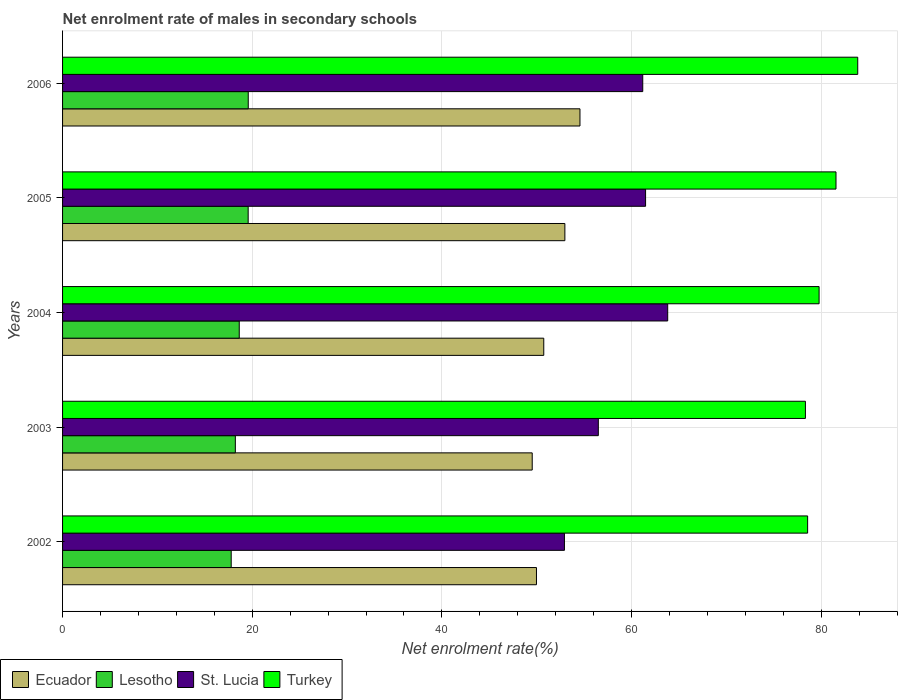How many different coloured bars are there?
Your answer should be very brief. 4. How many groups of bars are there?
Your answer should be very brief. 5. Are the number of bars per tick equal to the number of legend labels?
Ensure brevity in your answer.  Yes. Are the number of bars on each tick of the Y-axis equal?
Give a very brief answer. Yes. How many bars are there on the 5th tick from the top?
Your answer should be compact. 4. How many bars are there on the 3rd tick from the bottom?
Offer a terse response. 4. What is the label of the 3rd group of bars from the top?
Provide a short and direct response. 2004. What is the net enrolment rate of males in secondary schools in Turkey in 2003?
Your response must be concise. 78.34. Across all years, what is the maximum net enrolment rate of males in secondary schools in Turkey?
Your answer should be very brief. 83.85. Across all years, what is the minimum net enrolment rate of males in secondary schools in St. Lucia?
Make the answer very short. 52.92. In which year was the net enrolment rate of males in secondary schools in Ecuador maximum?
Ensure brevity in your answer.  2006. In which year was the net enrolment rate of males in secondary schools in Turkey minimum?
Provide a short and direct response. 2003. What is the total net enrolment rate of males in secondary schools in Turkey in the graph?
Offer a terse response. 402.09. What is the difference between the net enrolment rate of males in secondary schools in St. Lucia in 2003 and that in 2005?
Keep it short and to the point. -4.98. What is the difference between the net enrolment rate of males in secondary schools in St. Lucia in 2004 and the net enrolment rate of males in secondary schools in Lesotho in 2003?
Offer a very short reply. 45.59. What is the average net enrolment rate of males in secondary schools in Ecuador per year?
Offer a very short reply. 51.55. In the year 2005, what is the difference between the net enrolment rate of males in secondary schools in Ecuador and net enrolment rate of males in secondary schools in Turkey?
Your answer should be compact. -28.59. What is the ratio of the net enrolment rate of males in secondary schools in Ecuador in 2004 to that in 2006?
Make the answer very short. 0.93. Is the net enrolment rate of males in secondary schools in Turkey in 2002 less than that in 2006?
Keep it short and to the point. Yes. Is the difference between the net enrolment rate of males in secondary schools in Ecuador in 2002 and 2004 greater than the difference between the net enrolment rate of males in secondary schools in Turkey in 2002 and 2004?
Provide a succinct answer. Yes. What is the difference between the highest and the second highest net enrolment rate of males in secondary schools in Turkey?
Your answer should be very brief. 2.29. What is the difference between the highest and the lowest net enrolment rate of males in secondary schools in Turkey?
Keep it short and to the point. 5.52. Is the sum of the net enrolment rate of males in secondary schools in St. Lucia in 2002 and 2005 greater than the maximum net enrolment rate of males in secondary schools in Lesotho across all years?
Provide a succinct answer. Yes. Is it the case that in every year, the sum of the net enrolment rate of males in secondary schools in St. Lucia and net enrolment rate of males in secondary schools in Ecuador is greater than the sum of net enrolment rate of males in secondary schools in Lesotho and net enrolment rate of males in secondary schools in Turkey?
Offer a terse response. No. What does the 4th bar from the top in 2004 represents?
Offer a very short reply. Ecuador. What does the 2nd bar from the bottom in 2005 represents?
Keep it short and to the point. Lesotho. Are all the bars in the graph horizontal?
Offer a terse response. Yes. How many years are there in the graph?
Keep it short and to the point. 5. Does the graph contain grids?
Ensure brevity in your answer.  Yes. Where does the legend appear in the graph?
Offer a terse response. Bottom left. What is the title of the graph?
Your answer should be very brief. Net enrolment rate of males in secondary schools. Does "Azerbaijan" appear as one of the legend labels in the graph?
Ensure brevity in your answer.  No. What is the label or title of the X-axis?
Make the answer very short. Net enrolment rate(%). What is the label or title of the Y-axis?
Offer a terse response. Years. What is the Net enrolment rate(%) of Ecuador in 2002?
Offer a terse response. 49.97. What is the Net enrolment rate(%) in Lesotho in 2002?
Provide a succinct answer. 17.78. What is the Net enrolment rate(%) of St. Lucia in 2002?
Keep it short and to the point. 52.92. What is the Net enrolment rate(%) in Turkey in 2002?
Your response must be concise. 78.57. What is the Net enrolment rate(%) of Ecuador in 2003?
Your response must be concise. 49.53. What is the Net enrolment rate(%) of Lesotho in 2003?
Offer a terse response. 18.22. What is the Net enrolment rate(%) of St. Lucia in 2003?
Provide a succinct answer. 56.5. What is the Net enrolment rate(%) in Turkey in 2003?
Provide a succinct answer. 78.34. What is the Net enrolment rate(%) in Ecuador in 2004?
Keep it short and to the point. 50.74. What is the Net enrolment rate(%) in Lesotho in 2004?
Your response must be concise. 18.63. What is the Net enrolment rate(%) of St. Lucia in 2004?
Keep it short and to the point. 63.81. What is the Net enrolment rate(%) in Turkey in 2004?
Your answer should be compact. 79.78. What is the Net enrolment rate(%) of Ecuador in 2005?
Offer a terse response. 52.97. What is the Net enrolment rate(%) in Lesotho in 2005?
Provide a succinct answer. 19.57. What is the Net enrolment rate(%) in St. Lucia in 2005?
Your answer should be compact. 61.48. What is the Net enrolment rate(%) of Turkey in 2005?
Give a very brief answer. 81.56. What is the Net enrolment rate(%) in Ecuador in 2006?
Give a very brief answer. 54.56. What is the Net enrolment rate(%) in Lesotho in 2006?
Give a very brief answer. 19.58. What is the Net enrolment rate(%) in St. Lucia in 2006?
Provide a succinct answer. 61.18. What is the Net enrolment rate(%) in Turkey in 2006?
Offer a terse response. 83.85. Across all years, what is the maximum Net enrolment rate(%) of Ecuador?
Your answer should be compact. 54.56. Across all years, what is the maximum Net enrolment rate(%) of Lesotho?
Your response must be concise. 19.58. Across all years, what is the maximum Net enrolment rate(%) in St. Lucia?
Your answer should be compact. 63.81. Across all years, what is the maximum Net enrolment rate(%) in Turkey?
Your response must be concise. 83.85. Across all years, what is the minimum Net enrolment rate(%) of Ecuador?
Offer a very short reply. 49.53. Across all years, what is the minimum Net enrolment rate(%) of Lesotho?
Keep it short and to the point. 17.78. Across all years, what is the minimum Net enrolment rate(%) of St. Lucia?
Offer a terse response. 52.92. Across all years, what is the minimum Net enrolment rate(%) in Turkey?
Provide a succinct answer. 78.34. What is the total Net enrolment rate(%) in Ecuador in the graph?
Your answer should be very brief. 257.77. What is the total Net enrolment rate(%) of Lesotho in the graph?
Offer a very short reply. 93.79. What is the total Net enrolment rate(%) in St. Lucia in the graph?
Ensure brevity in your answer.  295.89. What is the total Net enrolment rate(%) of Turkey in the graph?
Give a very brief answer. 402.09. What is the difference between the Net enrolment rate(%) in Ecuador in 2002 and that in 2003?
Your answer should be very brief. 0.45. What is the difference between the Net enrolment rate(%) of Lesotho in 2002 and that in 2003?
Keep it short and to the point. -0.44. What is the difference between the Net enrolment rate(%) of St. Lucia in 2002 and that in 2003?
Provide a succinct answer. -3.57. What is the difference between the Net enrolment rate(%) in Turkey in 2002 and that in 2003?
Make the answer very short. 0.23. What is the difference between the Net enrolment rate(%) in Ecuador in 2002 and that in 2004?
Your answer should be compact. -0.77. What is the difference between the Net enrolment rate(%) of Lesotho in 2002 and that in 2004?
Your response must be concise. -0.85. What is the difference between the Net enrolment rate(%) of St. Lucia in 2002 and that in 2004?
Give a very brief answer. -10.89. What is the difference between the Net enrolment rate(%) in Turkey in 2002 and that in 2004?
Keep it short and to the point. -1.21. What is the difference between the Net enrolment rate(%) of Ecuador in 2002 and that in 2005?
Provide a succinct answer. -3. What is the difference between the Net enrolment rate(%) of Lesotho in 2002 and that in 2005?
Make the answer very short. -1.79. What is the difference between the Net enrolment rate(%) of St. Lucia in 2002 and that in 2005?
Offer a terse response. -8.56. What is the difference between the Net enrolment rate(%) in Turkey in 2002 and that in 2005?
Ensure brevity in your answer.  -2.99. What is the difference between the Net enrolment rate(%) in Ecuador in 2002 and that in 2006?
Make the answer very short. -4.59. What is the difference between the Net enrolment rate(%) of Lesotho in 2002 and that in 2006?
Provide a succinct answer. -1.8. What is the difference between the Net enrolment rate(%) of St. Lucia in 2002 and that in 2006?
Ensure brevity in your answer.  -8.26. What is the difference between the Net enrolment rate(%) of Turkey in 2002 and that in 2006?
Offer a terse response. -5.28. What is the difference between the Net enrolment rate(%) in Ecuador in 2003 and that in 2004?
Offer a terse response. -1.22. What is the difference between the Net enrolment rate(%) of Lesotho in 2003 and that in 2004?
Offer a very short reply. -0.41. What is the difference between the Net enrolment rate(%) in St. Lucia in 2003 and that in 2004?
Keep it short and to the point. -7.32. What is the difference between the Net enrolment rate(%) of Turkey in 2003 and that in 2004?
Offer a terse response. -1.44. What is the difference between the Net enrolment rate(%) in Ecuador in 2003 and that in 2005?
Offer a terse response. -3.44. What is the difference between the Net enrolment rate(%) of Lesotho in 2003 and that in 2005?
Your answer should be compact. -1.35. What is the difference between the Net enrolment rate(%) in St. Lucia in 2003 and that in 2005?
Keep it short and to the point. -4.98. What is the difference between the Net enrolment rate(%) in Turkey in 2003 and that in 2005?
Keep it short and to the point. -3.22. What is the difference between the Net enrolment rate(%) of Ecuador in 2003 and that in 2006?
Offer a very short reply. -5.04. What is the difference between the Net enrolment rate(%) in Lesotho in 2003 and that in 2006?
Ensure brevity in your answer.  -1.36. What is the difference between the Net enrolment rate(%) of St. Lucia in 2003 and that in 2006?
Your answer should be very brief. -4.68. What is the difference between the Net enrolment rate(%) in Turkey in 2003 and that in 2006?
Offer a terse response. -5.52. What is the difference between the Net enrolment rate(%) in Ecuador in 2004 and that in 2005?
Offer a very short reply. -2.23. What is the difference between the Net enrolment rate(%) in Lesotho in 2004 and that in 2005?
Ensure brevity in your answer.  -0.94. What is the difference between the Net enrolment rate(%) of St. Lucia in 2004 and that in 2005?
Offer a very short reply. 2.33. What is the difference between the Net enrolment rate(%) of Turkey in 2004 and that in 2005?
Keep it short and to the point. -1.78. What is the difference between the Net enrolment rate(%) of Ecuador in 2004 and that in 2006?
Provide a short and direct response. -3.82. What is the difference between the Net enrolment rate(%) in Lesotho in 2004 and that in 2006?
Offer a very short reply. -0.95. What is the difference between the Net enrolment rate(%) in St. Lucia in 2004 and that in 2006?
Offer a very short reply. 2.63. What is the difference between the Net enrolment rate(%) of Turkey in 2004 and that in 2006?
Provide a succinct answer. -4.07. What is the difference between the Net enrolment rate(%) in Ecuador in 2005 and that in 2006?
Provide a short and direct response. -1.59. What is the difference between the Net enrolment rate(%) in Lesotho in 2005 and that in 2006?
Ensure brevity in your answer.  -0.01. What is the difference between the Net enrolment rate(%) of St. Lucia in 2005 and that in 2006?
Keep it short and to the point. 0.3. What is the difference between the Net enrolment rate(%) of Turkey in 2005 and that in 2006?
Your response must be concise. -2.29. What is the difference between the Net enrolment rate(%) in Ecuador in 2002 and the Net enrolment rate(%) in Lesotho in 2003?
Ensure brevity in your answer.  31.75. What is the difference between the Net enrolment rate(%) of Ecuador in 2002 and the Net enrolment rate(%) of St. Lucia in 2003?
Provide a succinct answer. -6.52. What is the difference between the Net enrolment rate(%) of Ecuador in 2002 and the Net enrolment rate(%) of Turkey in 2003?
Provide a succinct answer. -28.36. What is the difference between the Net enrolment rate(%) in Lesotho in 2002 and the Net enrolment rate(%) in St. Lucia in 2003?
Keep it short and to the point. -38.72. What is the difference between the Net enrolment rate(%) of Lesotho in 2002 and the Net enrolment rate(%) of Turkey in 2003?
Provide a short and direct response. -60.55. What is the difference between the Net enrolment rate(%) in St. Lucia in 2002 and the Net enrolment rate(%) in Turkey in 2003?
Your answer should be very brief. -25.41. What is the difference between the Net enrolment rate(%) of Ecuador in 2002 and the Net enrolment rate(%) of Lesotho in 2004?
Provide a short and direct response. 31.34. What is the difference between the Net enrolment rate(%) in Ecuador in 2002 and the Net enrolment rate(%) in St. Lucia in 2004?
Your response must be concise. -13.84. What is the difference between the Net enrolment rate(%) in Ecuador in 2002 and the Net enrolment rate(%) in Turkey in 2004?
Keep it short and to the point. -29.8. What is the difference between the Net enrolment rate(%) of Lesotho in 2002 and the Net enrolment rate(%) of St. Lucia in 2004?
Make the answer very short. -46.03. What is the difference between the Net enrolment rate(%) in Lesotho in 2002 and the Net enrolment rate(%) in Turkey in 2004?
Provide a short and direct response. -61.99. What is the difference between the Net enrolment rate(%) of St. Lucia in 2002 and the Net enrolment rate(%) of Turkey in 2004?
Your answer should be very brief. -26.85. What is the difference between the Net enrolment rate(%) in Ecuador in 2002 and the Net enrolment rate(%) in Lesotho in 2005?
Your response must be concise. 30.4. What is the difference between the Net enrolment rate(%) in Ecuador in 2002 and the Net enrolment rate(%) in St. Lucia in 2005?
Offer a very short reply. -11.51. What is the difference between the Net enrolment rate(%) in Ecuador in 2002 and the Net enrolment rate(%) in Turkey in 2005?
Your response must be concise. -31.59. What is the difference between the Net enrolment rate(%) in Lesotho in 2002 and the Net enrolment rate(%) in St. Lucia in 2005?
Make the answer very short. -43.7. What is the difference between the Net enrolment rate(%) in Lesotho in 2002 and the Net enrolment rate(%) in Turkey in 2005?
Make the answer very short. -63.78. What is the difference between the Net enrolment rate(%) in St. Lucia in 2002 and the Net enrolment rate(%) in Turkey in 2005?
Ensure brevity in your answer.  -28.64. What is the difference between the Net enrolment rate(%) in Ecuador in 2002 and the Net enrolment rate(%) in Lesotho in 2006?
Provide a short and direct response. 30.39. What is the difference between the Net enrolment rate(%) of Ecuador in 2002 and the Net enrolment rate(%) of St. Lucia in 2006?
Keep it short and to the point. -11.21. What is the difference between the Net enrolment rate(%) in Ecuador in 2002 and the Net enrolment rate(%) in Turkey in 2006?
Provide a short and direct response. -33.88. What is the difference between the Net enrolment rate(%) in Lesotho in 2002 and the Net enrolment rate(%) in St. Lucia in 2006?
Offer a terse response. -43.4. What is the difference between the Net enrolment rate(%) in Lesotho in 2002 and the Net enrolment rate(%) in Turkey in 2006?
Keep it short and to the point. -66.07. What is the difference between the Net enrolment rate(%) of St. Lucia in 2002 and the Net enrolment rate(%) of Turkey in 2006?
Ensure brevity in your answer.  -30.93. What is the difference between the Net enrolment rate(%) in Ecuador in 2003 and the Net enrolment rate(%) in Lesotho in 2004?
Provide a short and direct response. 30.89. What is the difference between the Net enrolment rate(%) of Ecuador in 2003 and the Net enrolment rate(%) of St. Lucia in 2004?
Offer a very short reply. -14.29. What is the difference between the Net enrolment rate(%) in Ecuador in 2003 and the Net enrolment rate(%) in Turkey in 2004?
Provide a short and direct response. -30.25. What is the difference between the Net enrolment rate(%) of Lesotho in 2003 and the Net enrolment rate(%) of St. Lucia in 2004?
Keep it short and to the point. -45.59. What is the difference between the Net enrolment rate(%) in Lesotho in 2003 and the Net enrolment rate(%) in Turkey in 2004?
Offer a very short reply. -61.56. What is the difference between the Net enrolment rate(%) of St. Lucia in 2003 and the Net enrolment rate(%) of Turkey in 2004?
Offer a terse response. -23.28. What is the difference between the Net enrolment rate(%) of Ecuador in 2003 and the Net enrolment rate(%) of Lesotho in 2005?
Provide a succinct answer. 29.95. What is the difference between the Net enrolment rate(%) of Ecuador in 2003 and the Net enrolment rate(%) of St. Lucia in 2005?
Provide a short and direct response. -11.95. What is the difference between the Net enrolment rate(%) of Ecuador in 2003 and the Net enrolment rate(%) of Turkey in 2005?
Provide a short and direct response. -32.03. What is the difference between the Net enrolment rate(%) of Lesotho in 2003 and the Net enrolment rate(%) of St. Lucia in 2005?
Ensure brevity in your answer.  -43.26. What is the difference between the Net enrolment rate(%) in Lesotho in 2003 and the Net enrolment rate(%) in Turkey in 2005?
Ensure brevity in your answer.  -63.34. What is the difference between the Net enrolment rate(%) of St. Lucia in 2003 and the Net enrolment rate(%) of Turkey in 2005?
Ensure brevity in your answer.  -25.06. What is the difference between the Net enrolment rate(%) of Ecuador in 2003 and the Net enrolment rate(%) of Lesotho in 2006?
Your answer should be compact. 29.95. What is the difference between the Net enrolment rate(%) of Ecuador in 2003 and the Net enrolment rate(%) of St. Lucia in 2006?
Offer a terse response. -11.66. What is the difference between the Net enrolment rate(%) of Ecuador in 2003 and the Net enrolment rate(%) of Turkey in 2006?
Offer a very short reply. -34.33. What is the difference between the Net enrolment rate(%) in Lesotho in 2003 and the Net enrolment rate(%) in St. Lucia in 2006?
Provide a succinct answer. -42.96. What is the difference between the Net enrolment rate(%) in Lesotho in 2003 and the Net enrolment rate(%) in Turkey in 2006?
Offer a terse response. -65.63. What is the difference between the Net enrolment rate(%) of St. Lucia in 2003 and the Net enrolment rate(%) of Turkey in 2006?
Offer a very short reply. -27.35. What is the difference between the Net enrolment rate(%) in Ecuador in 2004 and the Net enrolment rate(%) in Lesotho in 2005?
Keep it short and to the point. 31.17. What is the difference between the Net enrolment rate(%) in Ecuador in 2004 and the Net enrolment rate(%) in St. Lucia in 2005?
Make the answer very short. -10.74. What is the difference between the Net enrolment rate(%) in Ecuador in 2004 and the Net enrolment rate(%) in Turkey in 2005?
Provide a succinct answer. -30.82. What is the difference between the Net enrolment rate(%) of Lesotho in 2004 and the Net enrolment rate(%) of St. Lucia in 2005?
Provide a succinct answer. -42.85. What is the difference between the Net enrolment rate(%) in Lesotho in 2004 and the Net enrolment rate(%) in Turkey in 2005?
Offer a terse response. -62.93. What is the difference between the Net enrolment rate(%) in St. Lucia in 2004 and the Net enrolment rate(%) in Turkey in 2005?
Offer a very short reply. -17.75. What is the difference between the Net enrolment rate(%) in Ecuador in 2004 and the Net enrolment rate(%) in Lesotho in 2006?
Provide a short and direct response. 31.16. What is the difference between the Net enrolment rate(%) in Ecuador in 2004 and the Net enrolment rate(%) in St. Lucia in 2006?
Your answer should be compact. -10.44. What is the difference between the Net enrolment rate(%) in Ecuador in 2004 and the Net enrolment rate(%) in Turkey in 2006?
Your response must be concise. -33.11. What is the difference between the Net enrolment rate(%) in Lesotho in 2004 and the Net enrolment rate(%) in St. Lucia in 2006?
Offer a terse response. -42.55. What is the difference between the Net enrolment rate(%) of Lesotho in 2004 and the Net enrolment rate(%) of Turkey in 2006?
Provide a short and direct response. -65.22. What is the difference between the Net enrolment rate(%) of St. Lucia in 2004 and the Net enrolment rate(%) of Turkey in 2006?
Your answer should be very brief. -20.04. What is the difference between the Net enrolment rate(%) of Ecuador in 2005 and the Net enrolment rate(%) of Lesotho in 2006?
Keep it short and to the point. 33.39. What is the difference between the Net enrolment rate(%) of Ecuador in 2005 and the Net enrolment rate(%) of St. Lucia in 2006?
Ensure brevity in your answer.  -8.21. What is the difference between the Net enrolment rate(%) of Ecuador in 2005 and the Net enrolment rate(%) of Turkey in 2006?
Offer a terse response. -30.88. What is the difference between the Net enrolment rate(%) in Lesotho in 2005 and the Net enrolment rate(%) in St. Lucia in 2006?
Provide a short and direct response. -41.61. What is the difference between the Net enrolment rate(%) in Lesotho in 2005 and the Net enrolment rate(%) in Turkey in 2006?
Offer a terse response. -64.28. What is the difference between the Net enrolment rate(%) of St. Lucia in 2005 and the Net enrolment rate(%) of Turkey in 2006?
Your answer should be very brief. -22.37. What is the average Net enrolment rate(%) in Ecuador per year?
Keep it short and to the point. 51.55. What is the average Net enrolment rate(%) in Lesotho per year?
Your response must be concise. 18.76. What is the average Net enrolment rate(%) in St. Lucia per year?
Keep it short and to the point. 59.18. What is the average Net enrolment rate(%) of Turkey per year?
Give a very brief answer. 80.42. In the year 2002, what is the difference between the Net enrolment rate(%) of Ecuador and Net enrolment rate(%) of Lesotho?
Offer a very short reply. 32.19. In the year 2002, what is the difference between the Net enrolment rate(%) in Ecuador and Net enrolment rate(%) in St. Lucia?
Ensure brevity in your answer.  -2.95. In the year 2002, what is the difference between the Net enrolment rate(%) in Ecuador and Net enrolment rate(%) in Turkey?
Offer a very short reply. -28.59. In the year 2002, what is the difference between the Net enrolment rate(%) in Lesotho and Net enrolment rate(%) in St. Lucia?
Keep it short and to the point. -35.14. In the year 2002, what is the difference between the Net enrolment rate(%) of Lesotho and Net enrolment rate(%) of Turkey?
Provide a short and direct response. -60.78. In the year 2002, what is the difference between the Net enrolment rate(%) in St. Lucia and Net enrolment rate(%) in Turkey?
Your answer should be very brief. -25.64. In the year 2003, what is the difference between the Net enrolment rate(%) in Ecuador and Net enrolment rate(%) in Lesotho?
Ensure brevity in your answer.  31.31. In the year 2003, what is the difference between the Net enrolment rate(%) in Ecuador and Net enrolment rate(%) in St. Lucia?
Your response must be concise. -6.97. In the year 2003, what is the difference between the Net enrolment rate(%) in Ecuador and Net enrolment rate(%) in Turkey?
Keep it short and to the point. -28.81. In the year 2003, what is the difference between the Net enrolment rate(%) in Lesotho and Net enrolment rate(%) in St. Lucia?
Provide a short and direct response. -38.28. In the year 2003, what is the difference between the Net enrolment rate(%) of Lesotho and Net enrolment rate(%) of Turkey?
Give a very brief answer. -60.12. In the year 2003, what is the difference between the Net enrolment rate(%) of St. Lucia and Net enrolment rate(%) of Turkey?
Offer a terse response. -21.84. In the year 2004, what is the difference between the Net enrolment rate(%) in Ecuador and Net enrolment rate(%) in Lesotho?
Ensure brevity in your answer.  32.11. In the year 2004, what is the difference between the Net enrolment rate(%) of Ecuador and Net enrolment rate(%) of St. Lucia?
Your answer should be compact. -13.07. In the year 2004, what is the difference between the Net enrolment rate(%) in Ecuador and Net enrolment rate(%) in Turkey?
Your answer should be compact. -29.03. In the year 2004, what is the difference between the Net enrolment rate(%) of Lesotho and Net enrolment rate(%) of St. Lucia?
Ensure brevity in your answer.  -45.18. In the year 2004, what is the difference between the Net enrolment rate(%) of Lesotho and Net enrolment rate(%) of Turkey?
Keep it short and to the point. -61.15. In the year 2004, what is the difference between the Net enrolment rate(%) in St. Lucia and Net enrolment rate(%) in Turkey?
Provide a succinct answer. -15.96. In the year 2005, what is the difference between the Net enrolment rate(%) of Ecuador and Net enrolment rate(%) of Lesotho?
Make the answer very short. 33.4. In the year 2005, what is the difference between the Net enrolment rate(%) of Ecuador and Net enrolment rate(%) of St. Lucia?
Give a very brief answer. -8.51. In the year 2005, what is the difference between the Net enrolment rate(%) of Ecuador and Net enrolment rate(%) of Turkey?
Give a very brief answer. -28.59. In the year 2005, what is the difference between the Net enrolment rate(%) of Lesotho and Net enrolment rate(%) of St. Lucia?
Give a very brief answer. -41.91. In the year 2005, what is the difference between the Net enrolment rate(%) in Lesotho and Net enrolment rate(%) in Turkey?
Your response must be concise. -61.99. In the year 2005, what is the difference between the Net enrolment rate(%) in St. Lucia and Net enrolment rate(%) in Turkey?
Give a very brief answer. -20.08. In the year 2006, what is the difference between the Net enrolment rate(%) of Ecuador and Net enrolment rate(%) of Lesotho?
Offer a terse response. 34.98. In the year 2006, what is the difference between the Net enrolment rate(%) of Ecuador and Net enrolment rate(%) of St. Lucia?
Your response must be concise. -6.62. In the year 2006, what is the difference between the Net enrolment rate(%) in Ecuador and Net enrolment rate(%) in Turkey?
Make the answer very short. -29.29. In the year 2006, what is the difference between the Net enrolment rate(%) of Lesotho and Net enrolment rate(%) of St. Lucia?
Make the answer very short. -41.6. In the year 2006, what is the difference between the Net enrolment rate(%) of Lesotho and Net enrolment rate(%) of Turkey?
Keep it short and to the point. -64.27. In the year 2006, what is the difference between the Net enrolment rate(%) of St. Lucia and Net enrolment rate(%) of Turkey?
Ensure brevity in your answer.  -22.67. What is the ratio of the Net enrolment rate(%) of Ecuador in 2002 to that in 2003?
Offer a very short reply. 1.01. What is the ratio of the Net enrolment rate(%) of Lesotho in 2002 to that in 2003?
Provide a short and direct response. 0.98. What is the ratio of the Net enrolment rate(%) of St. Lucia in 2002 to that in 2003?
Your answer should be very brief. 0.94. What is the ratio of the Net enrolment rate(%) of Turkey in 2002 to that in 2003?
Your response must be concise. 1. What is the ratio of the Net enrolment rate(%) of Ecuador in 2002 to that in 2004?
Provide a short and direct response. 0.98. What is the ratio of the Net enrolment rate(%) in Lesotho in 2002 to that in 2004?
Provide a succinct answer. 0.95. What is the ratio of the Net enrolment rate(%) in St. Lucia in 2002 to that in 2004?
Offer a very short reply. 0.83. What is the ratio of the Net enrolment rate(%) in Ecuador in 2002 to that in 2005?
Offer a terse response. 0.94. What is the ratio of the Net enrolment rate(%) in Lesotho in 2002 to that in 2005?
Ensure brevity in your answer.  0.91. What is the ratio of the Net enrolment rate(%) of St. Lucia in 2002 to that in 2005?
Your answer should be very brief. 0.86. What is the ratio of the Net enrolment rate(%) in Turkey in 2002 to that in 2005?
Provide a short and direct response. 0.96. What is the ratio of the Net enrolment rate(%) in Ecuador in 2002 to that in 2006?
Keep it short and to the point. 0.92. What is the ratio of the Net enrolment rate(%) in Lesotho in 2002 to that in 2006?
Provide a short and direct response. 0.91. What is the ratio of the Net enrolment rate(%) in St. Lucia in 2002 to that in 2006?
Your response must be concise. 0.86. What is the ratio of the Net enrolment rate(%) in Turkey in 2002 to that in 2006?
Provide a succinct answer. 0.94. What is the ratio of the Net enrolment rate(%) of Lesotho in 2003 to that in 2004?
Provide a succinct answer. 0.98. What is the ratio of the Net enrolment rate(%) of St. Lucia in 2003 to that in 2004?
Your response must be concise. 0.89. What is the ratio of the Net enrolment rate(%) in Turkey in 2003 to that in 2004?
Give a very brief answer. 0.98. What is the ratio of the Net enrolment rate(%) in Ecuador in 2003 to that in 2005?
Give a very brief answer. 0.94. What is the ratio of the Net enrolment rate(%) in Lesotho in 2003 to that in 2005?
Provide a succinct answer. 0.93. What is the ratio of the Net enrolment rate(%) in St. Lucia in 2003 to that in 2005?
Ensure brevity in your answer.  0.92. What is the ratio of the Net enrolment rate(%) in Turkey in 2003 to that in 2005?
Keep it short and to the point. 0.96. What is the ratio of the Net enrolment rate(%) of Ecuador in 2003 to that in 2006?
Keep it short and to the point. 0.91. What is the ratio of the Net enrolment rate(%) of Lesotho in 2003 to that in 2006?
Your response must be concise. 0.93. What is the ratio of the Net enrolment rate(%) of St. Lucia in 2003 to that in 2006?
Your response must be concise. 0.92. What is the ratio of the Net enrolment rate(%) of Turkey in 2003 to that in 2006?
Offer a very short reply. 0.93. What is the ratio of the Net enrolment rate(%) in Ecuador in 2004 to that in 2005?
Ensure brevity in your answer.  0.96. What is the ratio of the Net enrolment rate(%) in Lesotho in 2004 to that in 2005?
Provide a short and direct response. 0.95. What is the ratio of the Net enrolment rate(%) in St. Lucia in 2004 to that in 2005?
Offer a terse response. 1.04. What is the ratio of the Net enrolment rate(%) of Turkey in 2004 to that in 2005?
Make the answer very short. 0.98. What is the ratio of the Net enrolment rate(%) in Lesotho in 2004 to that in 2006?
Keep it short and to the point. 0.95. What is the ratio of the Net enrolment rate(%) in St. Lucia in 2004 to that in 2006?
Keep it short and to the point. 1.04. What is the ratio of the Net enrolment rate(%) in Turkey in 2004 to that in 2006?
Provide a succinct answer. 0.95. What is the ratio of the Net enrolment rate(%) in Ecuador in 2005 to that in 2006?
Your answer should be very brief. 0.97. What is the ratio of the Net enrolment rate(%) in Lesotho in 2005 to that in 2006?
Offer a very short reply. 1. What is the ratio of the Net enrolment rate(%) in St. Lucia in 2005 to that in 2006?
Your answer should be compact. 1. What is the ratio of the Net enrolment rate(%) in Turkey in 2005 to that in 2006?
Keep it short and to the point. 0.97. What is the difference between the highest and the second highest Net enrolment rate(%) in Ecuador?
Your response must be concise. 1.59. What is the difference between the highest and the second highest Net enrolment rate(%) of Lesotho?
Provide a succinct answer. 0.01. What is the difference between the highest and the second highest Net enrolment rate(%) in St. Lucia?
Provide a succinct answer. 2.33. What is the difference between the highest and the second highest Net enrolment rate(%) of Turkey?
Offer a very short reply. 2.29. What is the difference between the highest and the lowest Net enrolment rate(%) in Ecuador?
Give a very brief answer. 5.04. What is the difference between the highest and the lowest Net enrolment rate(%) of Lesotho?
Offer a terse response. 1.8. What is the difference between the highest and the lowest Net enrolment rate(%) of St. Lucia?
Offer a very short reply. 10.89. What is the difference between the highest and the lowest Net enrolment rate(%) in Turkey?
Provide a succinct answer. 5.52. 